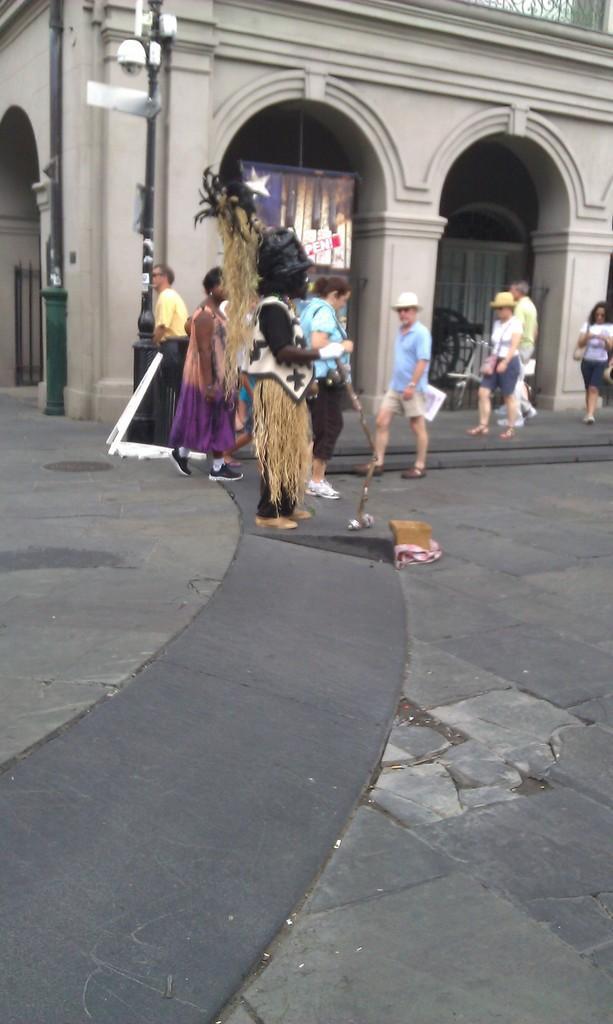Can you describe this image briefly? Here we can see few persons walking on the road and among them a person in the middle is holding an object in the hand and there is an object on the road. In the background there is a building,poles,banner and some other items. 